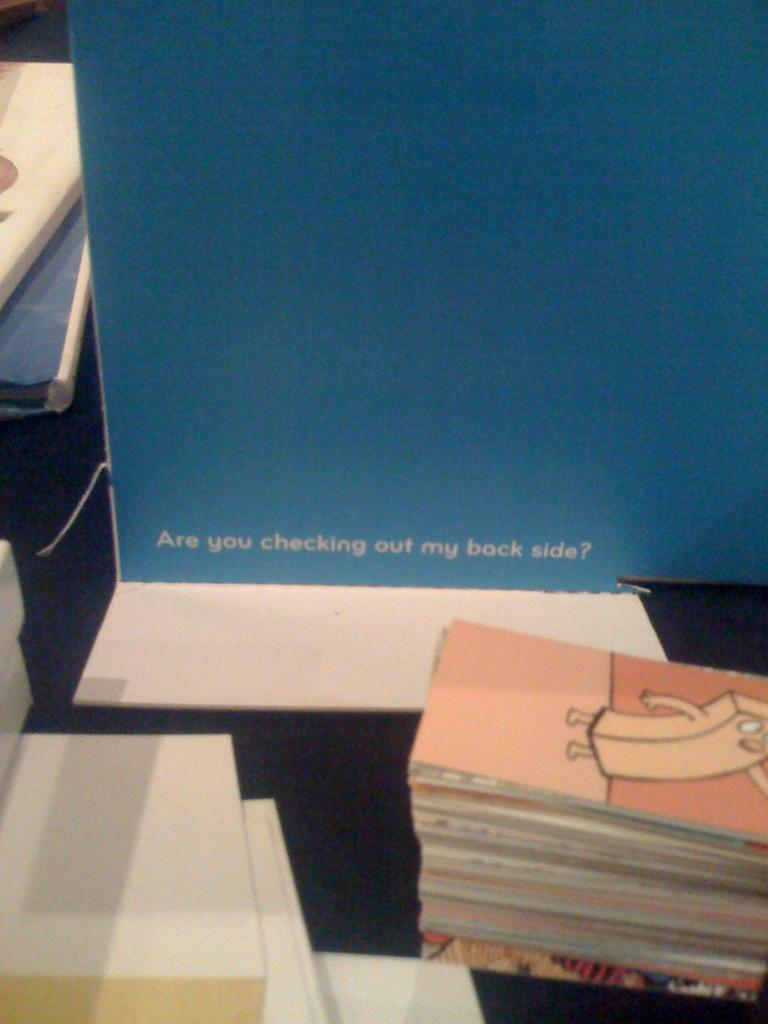Provide a one-sentence caption for the provided image. A placard that says "Are you checking out my back side?" is sitting on a table. 